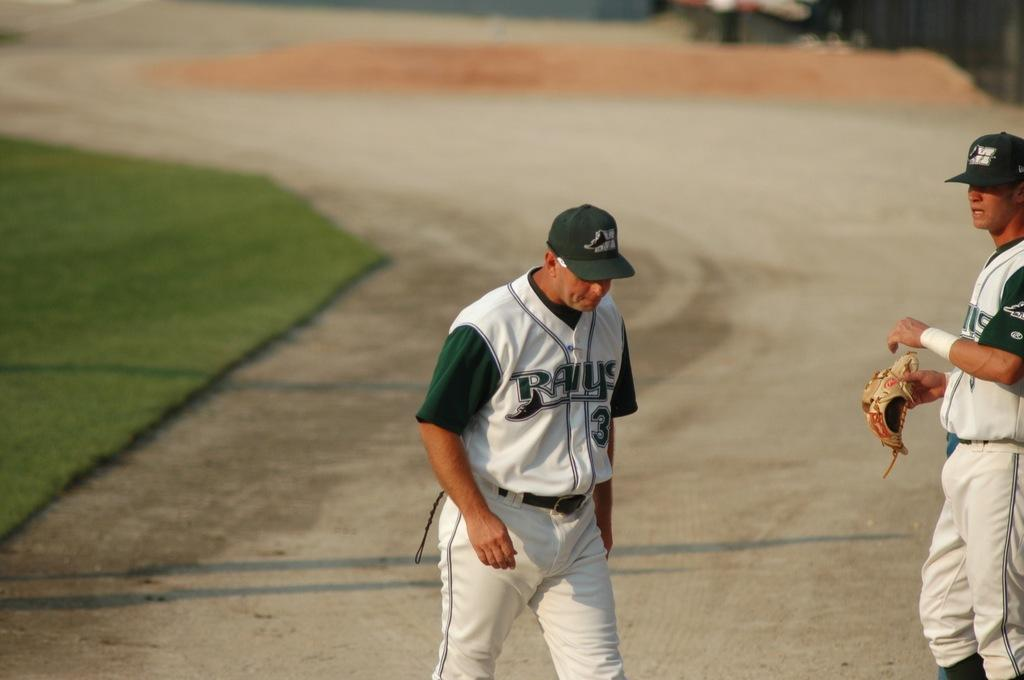<image>
Offer a succinct explanation of the picture presented. A man in a Rays baseball uniform walks on the dirt of a baseball field. 